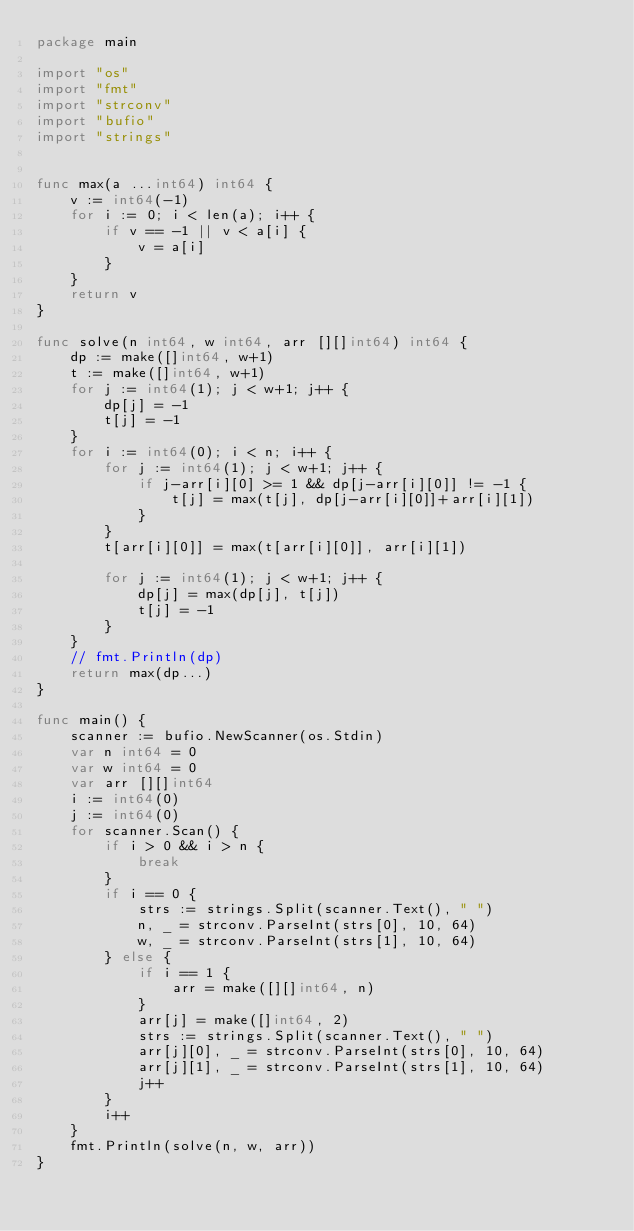<code> <loc_0><loc_0><loc_500><loc_500><_Go_>package main

import "os"
import "fmt"
import "strconv"
import "bufio"
import "strings"


func max(a ...int64) int64 {
    v := int64(-1)
    for i := 0; i < len(a); i++ {
        if v == -1 || v < a[i] {
            v = a[i]
        }
    }
    return v
}

func solve(n int64, w int64, arr [][]int64) int64 {
    dp := make([]int64, w+1)
    t := make([]int64, w+1)
    for j := int64(1); j < w+1; j++ {
        dp[j] = -1
        t[j] = -1
    }
    for i := int64(0); i < n; i++ {
        for j := int64(1); j < w+1; j++ {
            if j-arr[i][0] >= 1 && dp[j-arr[i][0]] != -1 {
                t[j] = max(t[j], dp[j-arr[i][0]]+arr[i][1])
            }
        }
        t[arr[i][0]] = max(t[arr[i][0]], arr[i][1])

        for j := int64(1); j < w+1; j++ {
            dp[j] = max(dp[j], t[j])
            t[j] = -1
        }
    }
    // fmt.Println(dp)
    return max(dp...)
}

func main() {
    scanner := bufio.NewScanner(os.Stdin)
    var n int64 = 0
    var w int64 = 0
    var arr [][]int64
    i := int64(0)
    j := int64(0)
    for scanner.Scan() {
        if i > 0 && i > n {
            break
        }
        if i == 0 {
            strs := strings.Split(scanner.Text(), " ")
            n, _ = strconv.ParseInt(strs[0], 10, 64)
            w, _ = strconv.ParseInt(strs[1], 10, 64)
        } else {
            if i == 1 {
                arr = make([][]int64, n)
            }
            arr[j] = make([]int64, 2)
            strs := strings.Split(scanner.Text(), " ")
            arr[j][0], _ = strconv.ParseInt(strs[0], 10, 64)
            arr[j][1], _ = strconv.ParseInt(strs[1], 10, 64)
            j++
        }
        i++ 
    }
    fmt.Println(solve(n, w, arr))
}</code> 